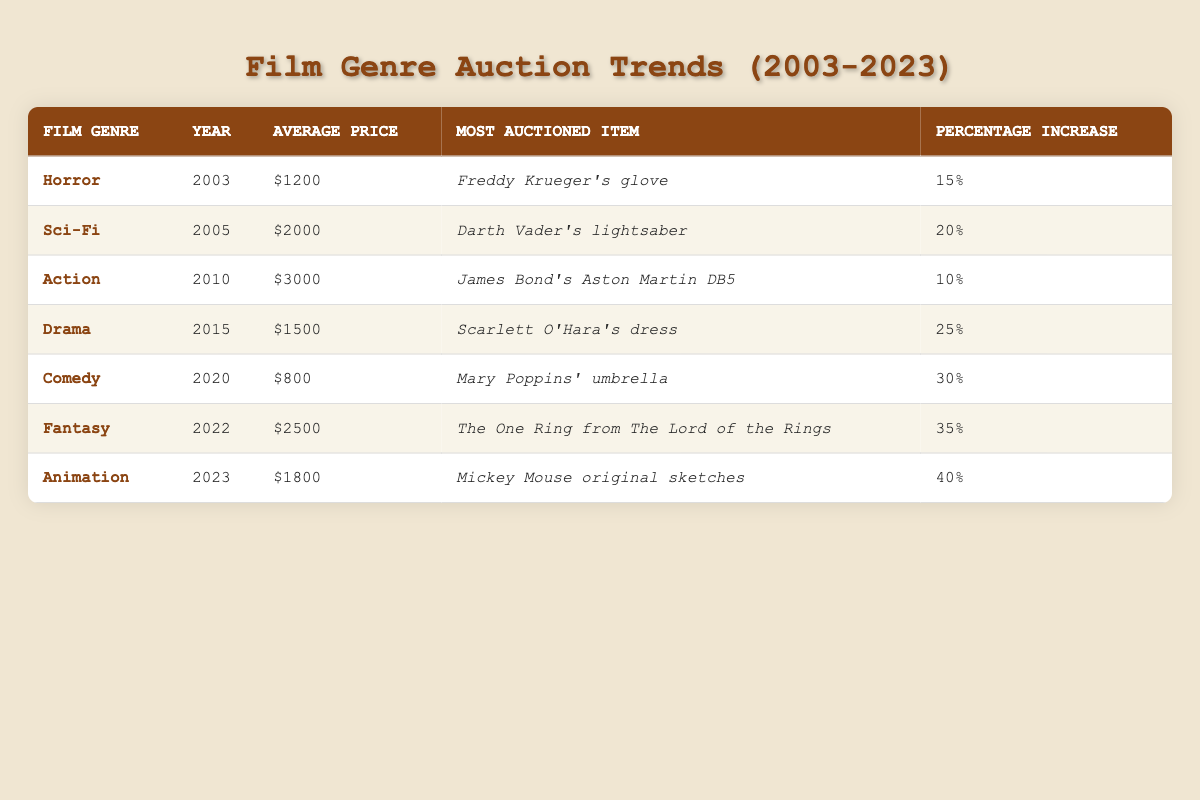What was the average price of auction items for the Horror genre in 2003? According to the table, the average price for the Horror genre in 2003 is $1200, as listed in the corresponding row.
Answer: 1200 Which film genre had the highest average price at auction, and what was that price? By examining the table, the Action genre had the highest average price at $3000, as indicated in its row.
Answer: Action, 3000 What percentage increase did the average price for the Animation genre experience from the previous year? The Animation genre in 2023 shows a 40 percent increase, which is provided in the table. There is no previous year data for Animation, so the percentage increase refers strictly to the current trends.
Answer: 40 True or False: The most auctioned item for the Comedy genre was more expensive than the most auctioned item for the Horror genre. The most auctioned item for Comedy is Mary Poppins' umbrella priced at $800, while for Horror it's Freddy Krueger's glove priced at $1200. Since $800 is less than $1200, the statement is false.
Answer: False Which genre had the most significant percentage increase in auction prices over the 20 years reflected in the table? By comparing the percentage increases listed, Fantasy had the most significant increase at 35 percent, while Animation exceeded this with 40 percent, which shows more significant growth when considering the years.
Answer: Animation, 40 